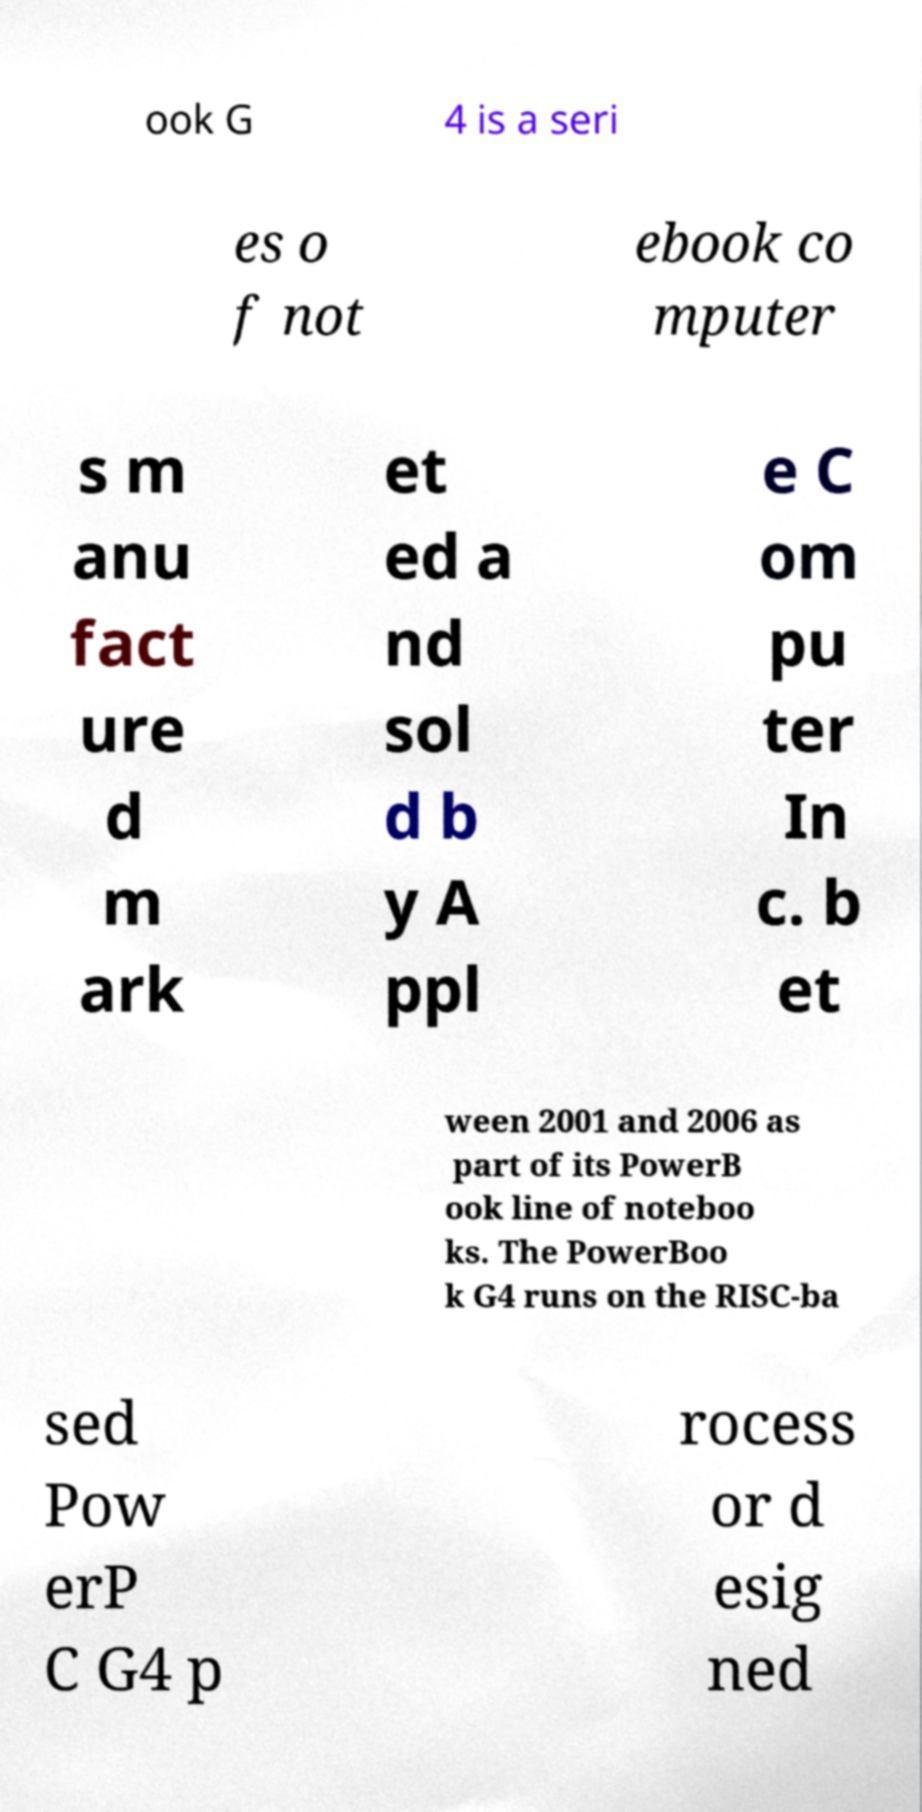Can you accurately transcribe the text from the provided image for me? ook G 4 is a seri es o f not ebook co mputer s m anu fact ure d m ark et ed a nd sol d b y A ppl e C om pu ter In c. b et ween 2001 and 2006 as part of its PowerB ook line of noteboo ks. The PowerBoo k G4 runs on the RISC-ba sed Pow erP C G4 p rocess or d esig ned 